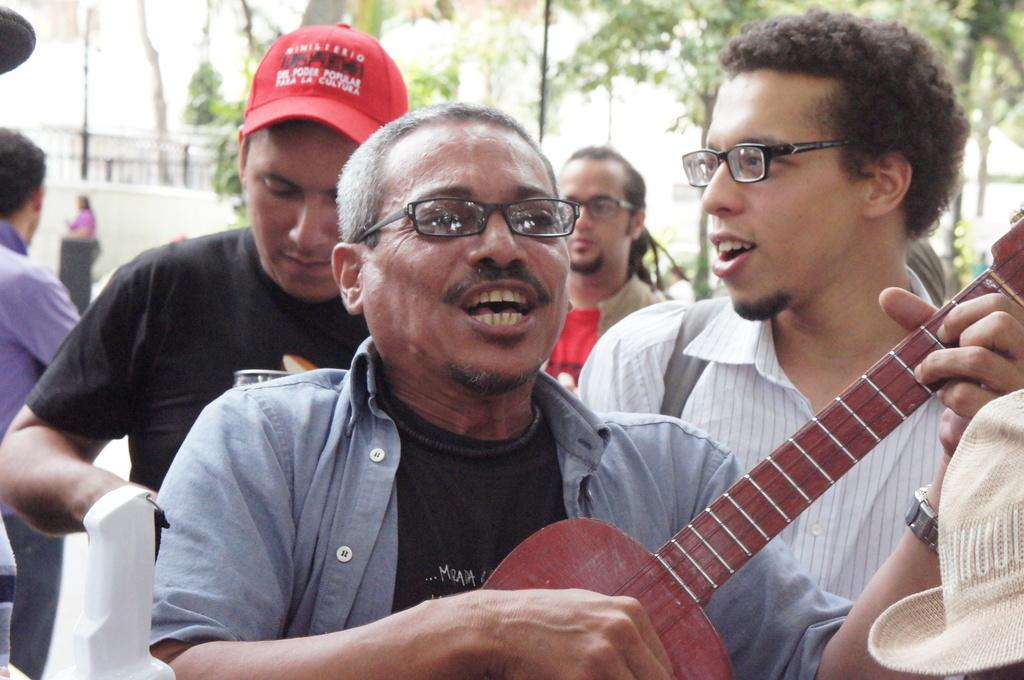What is happening in the image involving a group of people? There is a group of people in the image, and one person is holding a musical instrument. Can you describe the appearance of some individuals in the group? Three persons in the group are wearing glasses. What can be seen in the background of the image? There are trees and a wall in the background of the image. How many children are playing with the ray in the image? There is no ray or children present in the image. What type of beggar can be seen interacting with the group of people? There is no beggar present in the image; it only features a group of people and a musical instrument. 